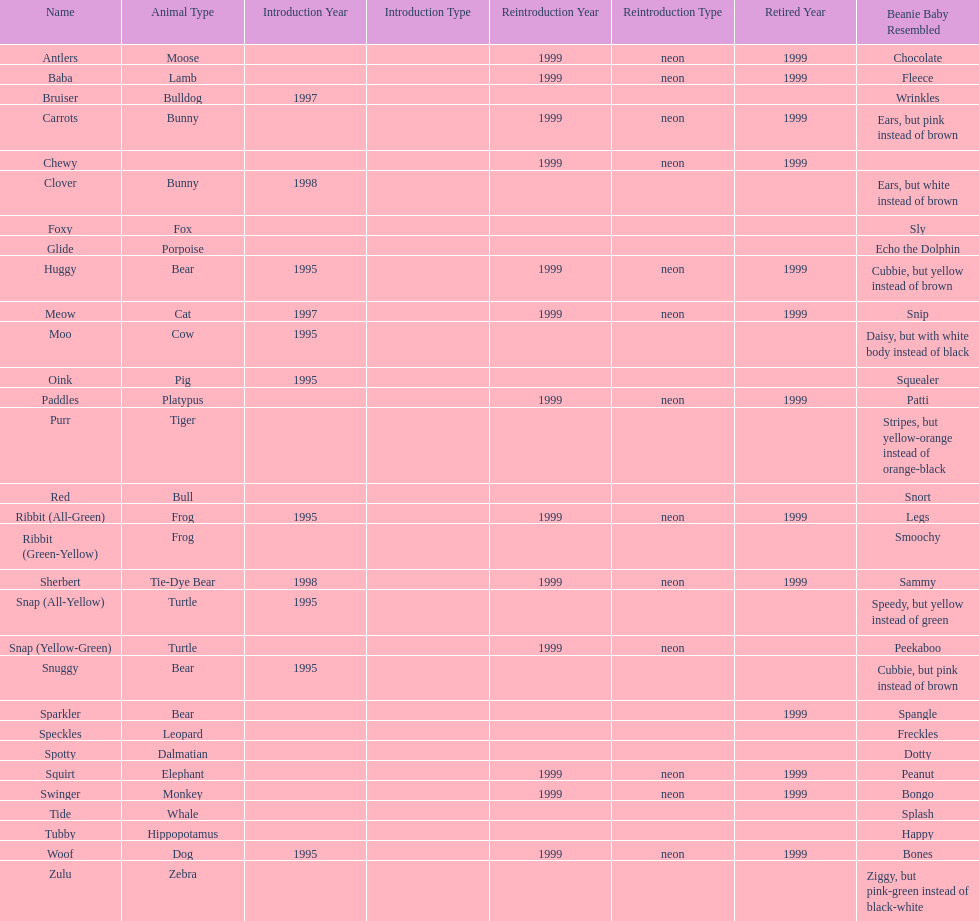What is the name of the pillow pal listed after clover? Foxy. 